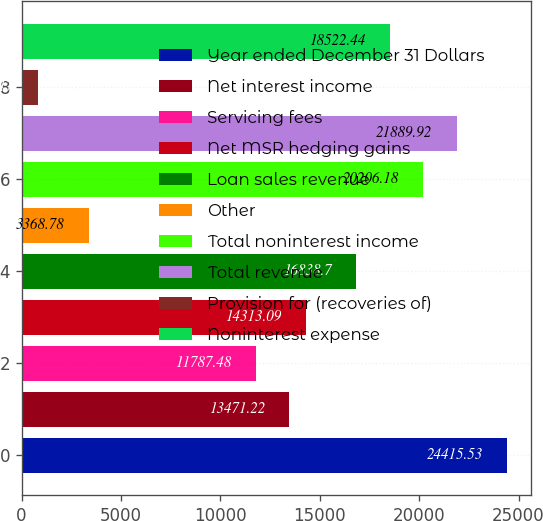Convert chart to OTSL. <chart><loc_0><loc_0><loc_500><loc_500><bar_chart><fcel>Year ended December 31 Dollars<fcel>Net interest income<fcel>Servicing fees<fcel>Net MSR hedging gains<fcel>Loan sales revenue<fcel>Other<fcel>Total noninterest income<fcel>Total revenue<fcel>Provision for (recoveries of)<fcel>Noninterest expense<nl><fcel>24415.5<fcel>13471.2<fcel>11787.5<fcel>14313.1<fcel>16838.7<fcel>3368.78<fcel>20206.2<fcel>21889.9<fcel>843.17<fcel>18522.4<nl></chart> 